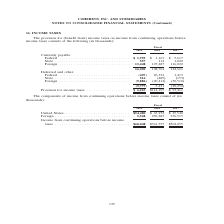According to Coherent's financial document, What was the Provision for income taxes in 2019? According to the financial document, $6,223 (in thousands). The relevant text states: "77) 5,431 (29,250) Provision for income taxes . $ 6,223 $114,195 $ 93,411..." Also, What was the currently payable federal income tax in 2019? According to the financial document, $1,995 (in thousands). The relevant text states: "Currently payable: Federal . $ 1,995 $ 1,163 $ 5,617 State . 557 114 1,022 Foreign . 13,448 107,487 116,022 16,000 108,764 122,661 Defer..." Also, In which years was provision for income taxes calculated? The document contains multiple relevant values: 2019, 2018, 2017. From the document: "Fiscal 2019 2018 2017 Fiscal 2019 2018 2017 Fiscal 2019 2018 2017..." Additionally, In which year was Provision for income taxes largest? According to the financial document, 2018. The relevant text states: "Fiscal 2019 2018 2017..." Also, can you calculate: What was the change in state income taxes that is currently payable in 2019 from 2018? Based on the calculation: 557-114, the result is 443 (in thousands). This is based on the information: "ayable: Federal . $ 1,995 $ 1,163 $ 5,617 State . 557 114 1,022 Foreign . 13,448 107,487 116,022 16,000 108,764 122,661 Deferred and other: Federal . (40 le: Federal . $ 1,995 $ 1,163 $ 5,617 State . ..." The key data points involved are: 114, 557. Also, can you calculate: What was the percentage change in state income taxes that is currently payable in 2019 from 2018? To answer this question, I need to perform calculations using the financial data. The calculation is: (557-114)/114, which equals 388.6 (percentage). This is based on the information: "ayable: Federal . $ 1,995 $ 1,163 $ 5,617 State . 557 114 1,022 Foreign . 13,448 107,487 116,022 16,000 108,764 122,661 Deferred and other: Federal . (40 le: Federal . $ 1,995 $ 1,163 $ 5,617 State . ..." The key data points involved are: 114, 557. 